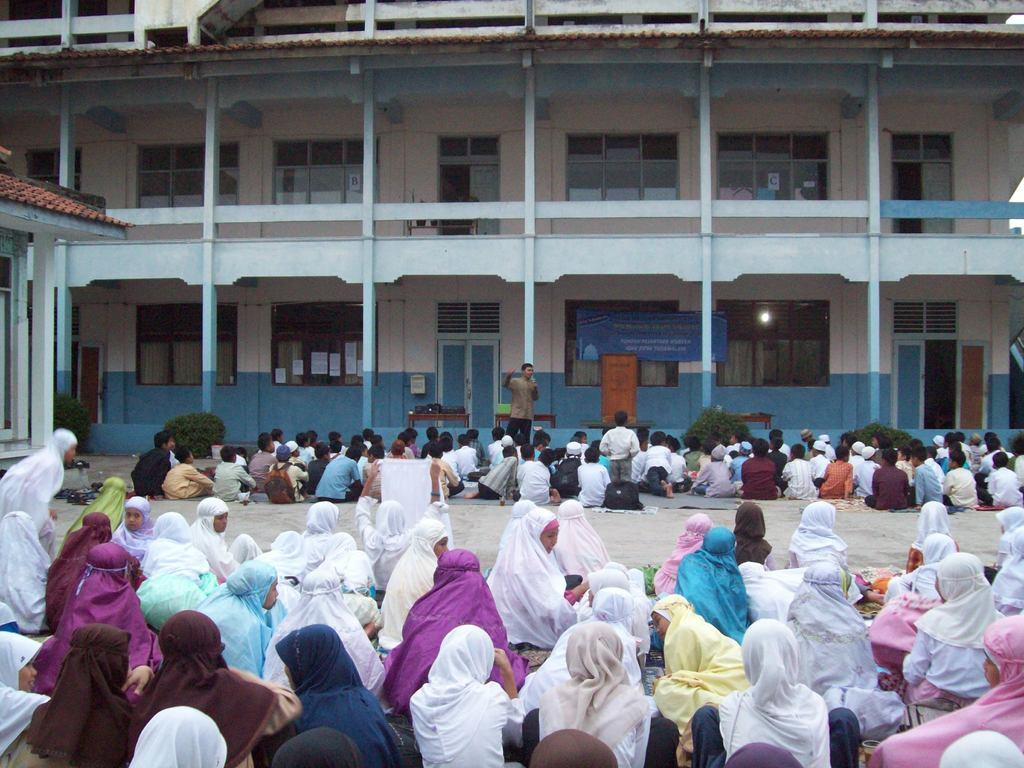What are the people in the image doing? There are groups of persons sitting on the ground in the image. Can you describe the person in the background? There is a person standing and speaking in the background. What can be seen in the distance behind the people? There are buildings in the background. What features do the buildings have? The buildings have glass windows and pillars. Can you tell me how many snails are crawling on the person speaking in the background? There are no snails present in the image, so it is not possible to determine how many would be crawling on the person speaking. 